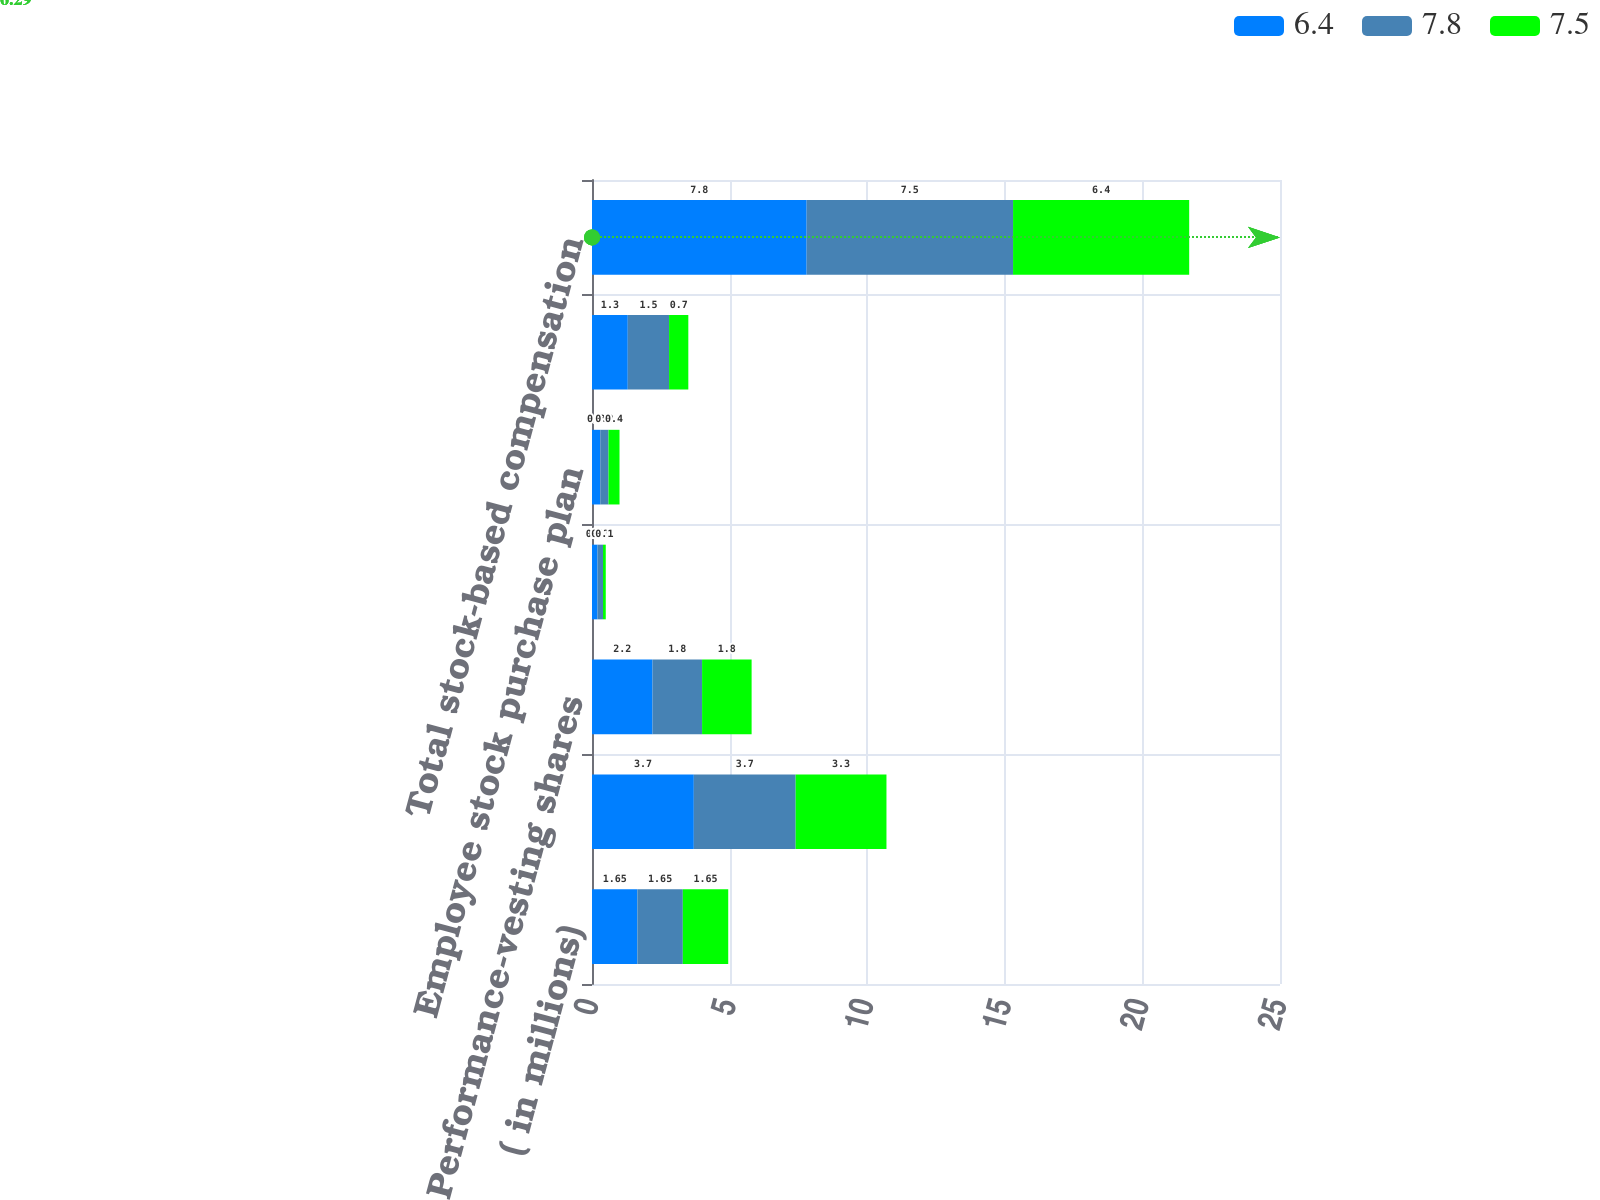Convert chart to OTSL. <chart><loc_0><loc_0><loc_500><loc_500><stacked_bar_chart><ecel><fcel>( in millions)<fcel>Stock option and appreciation<fcel>Performance-vesting shares<fcel>Performance-vesting<fcel>Employee stock purchase plan<fcel>Deferred compensation plans<fcel>Total stock-based compensation<nl><fcel>6.4<fcel>1.65<fcel>3.7<fcel>2.2<fcel>0.2<fcel>0.3<fcel>1.3<fcel>7.8<nl><fcel>7.8<fcel>1.65<fcel>3.7<fcel>1.8<fcel>0.2<fcel>0.3<fcel>1.5<fcel>7.5<nl><fcel>7.5<fcel>1.65<fcel>3.3<fcel>1.8<fcel>0.1<fcel>0.4<fcel>0.7<fcel>6.4<nl></chart> 